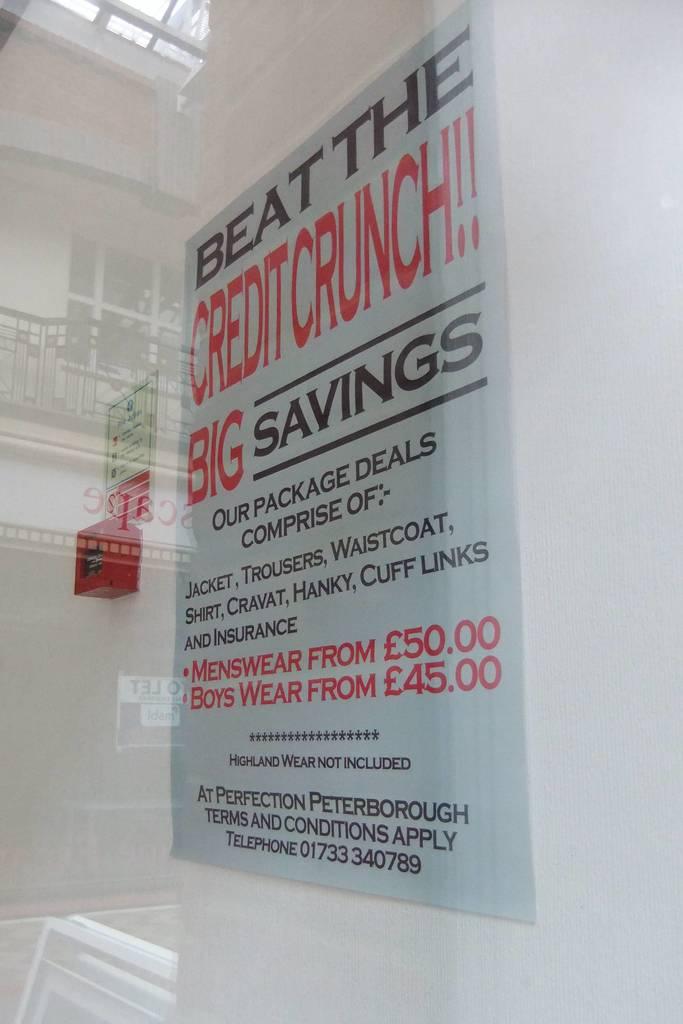Does the poster offer big savings?
Make the answer very short. Yes. How much is menswear?
Offer a terse response. 50.00. 